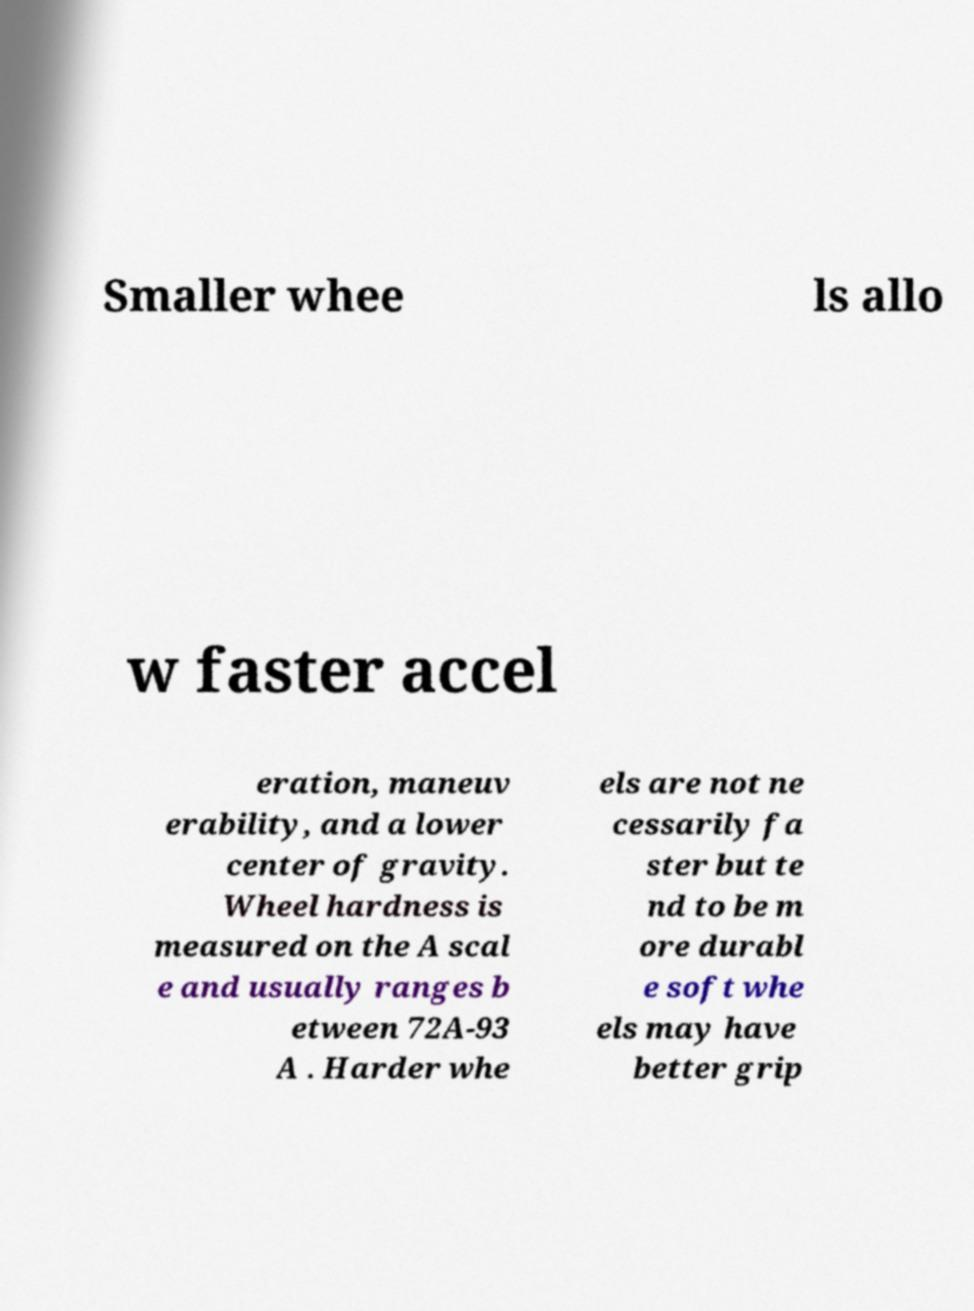Could you extract and type out the text from this image? Smaller whee ls allo w faster accel eration, maneuv erability, and a lower center of gravity. Wheel hardness is measured on the A scal e and usually ranges b etween 72A-93 A . Harder whe els are not ne cessarily fa ster but te nd to be m ore durabl e soft whe els may have better grip 